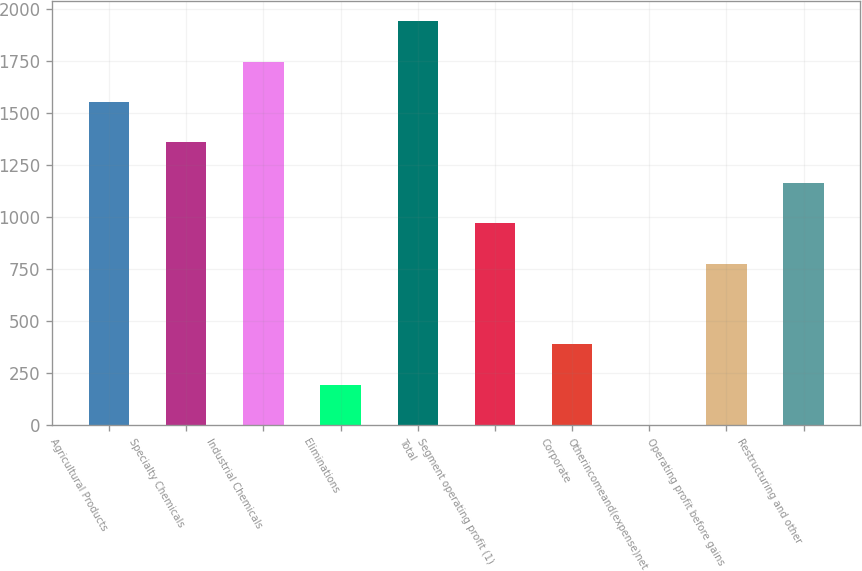<chart> <loc_0><loc_0><loc_500><loc_500><bar_chart><fcel>Agricultural Products<fcel>Specialty Chemicals<fcel>Industrial Chemicals<fcel>Eliminations<fcel>Total<fcel>Segment operating profit (1)<fcel>Corporate<fcel>Otherincomeand(expense)net<fcel>Operating profit before gains<fcel>Restructuring and other<nl><fcel>1554.72<fcel>1360.58<fcel>1748.86<fcel>195.74<fcel>1943<fcel>972.3<fcel>389.88<fcel>1.6<fcel>778.16<fcel>1166.44<nl></chart> 